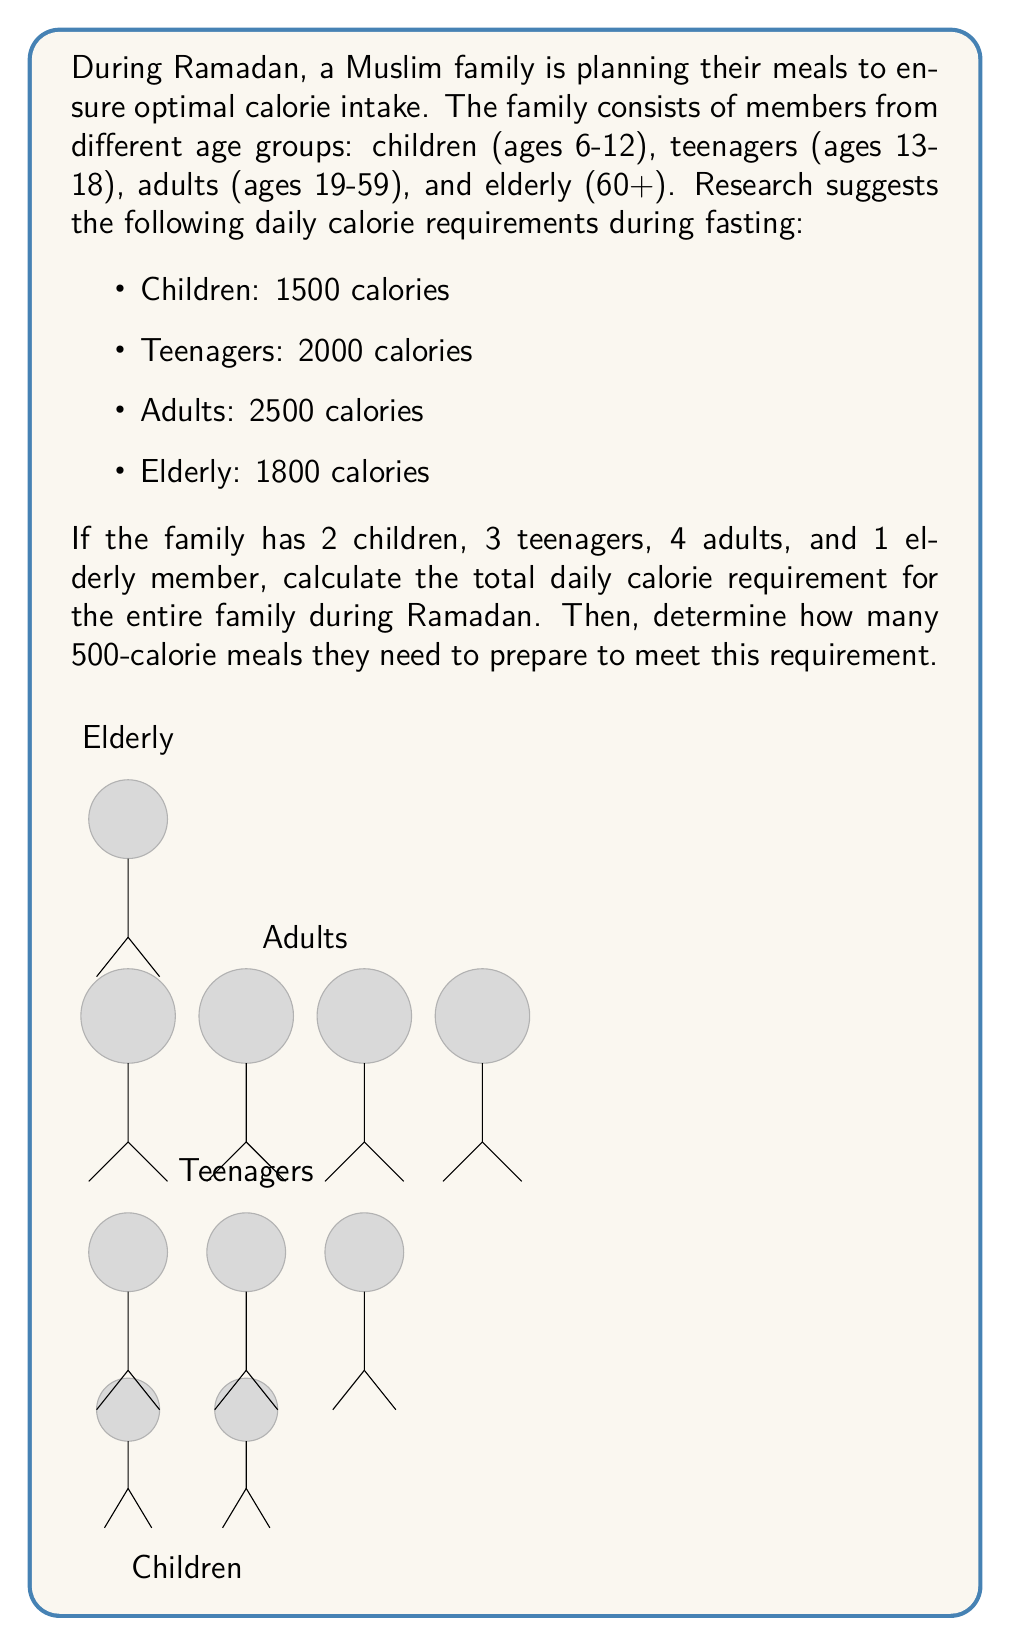Provide a solution to this math problem. Let's approach this problem step-by-step:

1) First, we need to calculate the total calorie requirement for each age group:

   Children: $2 \times 1500 = 3000$ calories
   Teenagers: $3 \times 2000 = 6000$ calories
   Adults: $4 \times 2500 = 10000$ calories
   Elderly: $1 \times 1800 = 1800$ calories

2) Now, we sum up these values to get the total family requirement:

   $\text{Total} = 3000 + 6000 + 10000 + 1800 = 20800$ calories

3) To determine how many 500-calorie meals are needed, we divide the total by 500:

   $\text{Number of meals} = \frac{20800}{500} = 41.6$

4) Since we can't prepare a fraction of a meal, we round up to the nearest whole number:

   $\text{Number of meals} = \lceil 41.6 \rceil = 42$

Therefore, the family needs to prepare 42 meals of 500 calories each to meet their daily calorie requirement during Ramadan.
Answer: 42 meals 